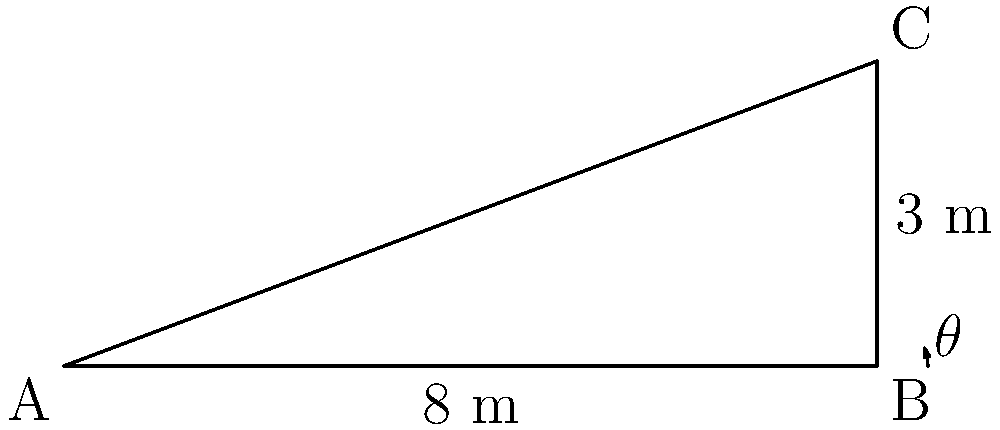As part of designing a new bike ramp for a local park, you need to determine the optimal angle for rider safety and comfort. The ramp will be 8 meters long and rise to a height of 3 meters. What is the angle $\theta$ (in degrees, rounded to the nearest whole number) that the ramp makes with the ground? To solve this problem, we'll use trigonometry:

1) We have a right triangle where:
   - The adjacent side (base of the ramp) is 8 meters
   - The opposite side (height of the ramp) is 3 meters
   - We need to find the angle $\theta$

2) The tangent of an angle in a right triangle is the ratio of the opposite side to the adjacent side:

   $$\tan(\theta) = \frac{\text{opposite}}{\text{adjacent}} = \frac{3}{8}$$

3) To find $\theta$, we need to use the inverse tangent (arctangent) function:

   $$\theta = \arctan(\frac{3}{8})$$

4) Using a calculator or programming function:

   $$\theta \approx 20.556°$$

5) Rounding to the nearest whole number:

   $$\theta \approx 21°$$

This angle provides a good balance between slope and length for most cyclists, ensuring safety and comfort while riding up the ramp.
Answer: 21° 